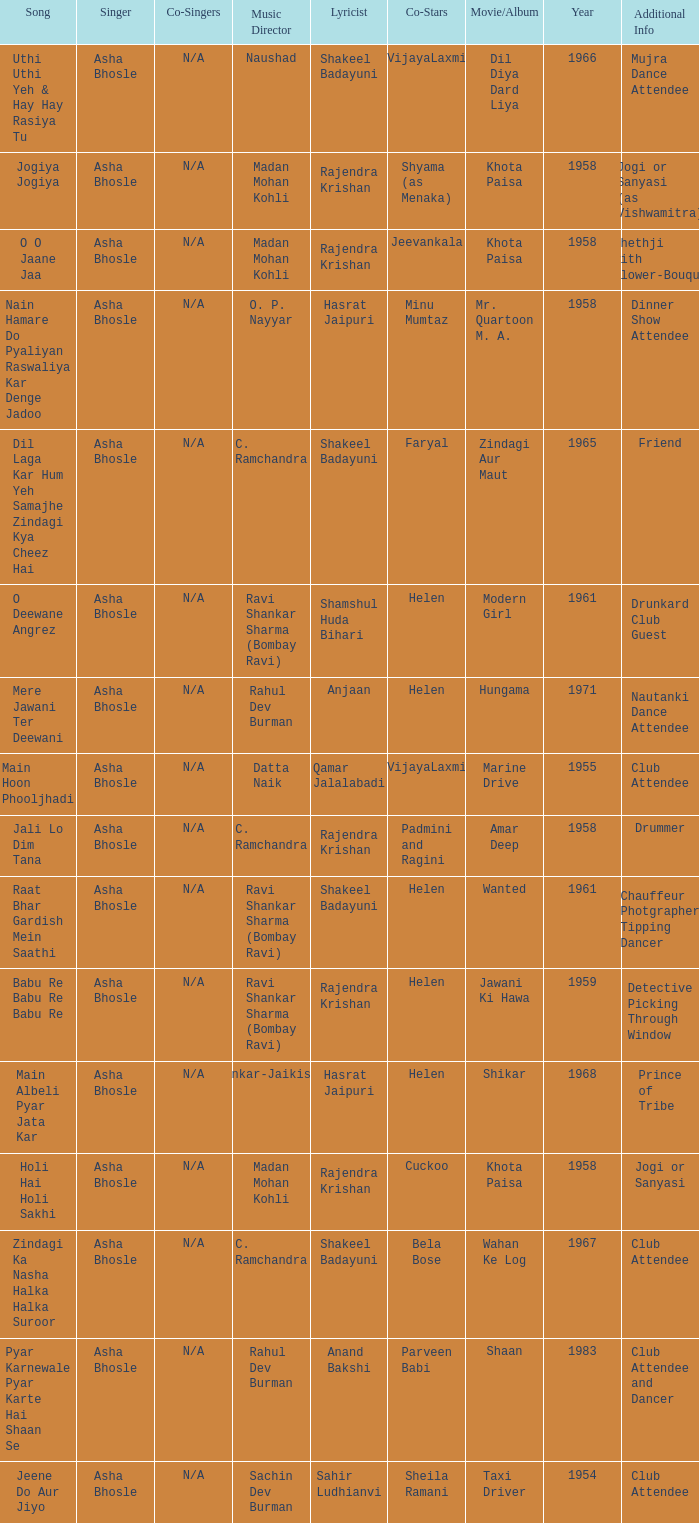What movie did Bela Bose co-star in? Wahan Ke Log. 